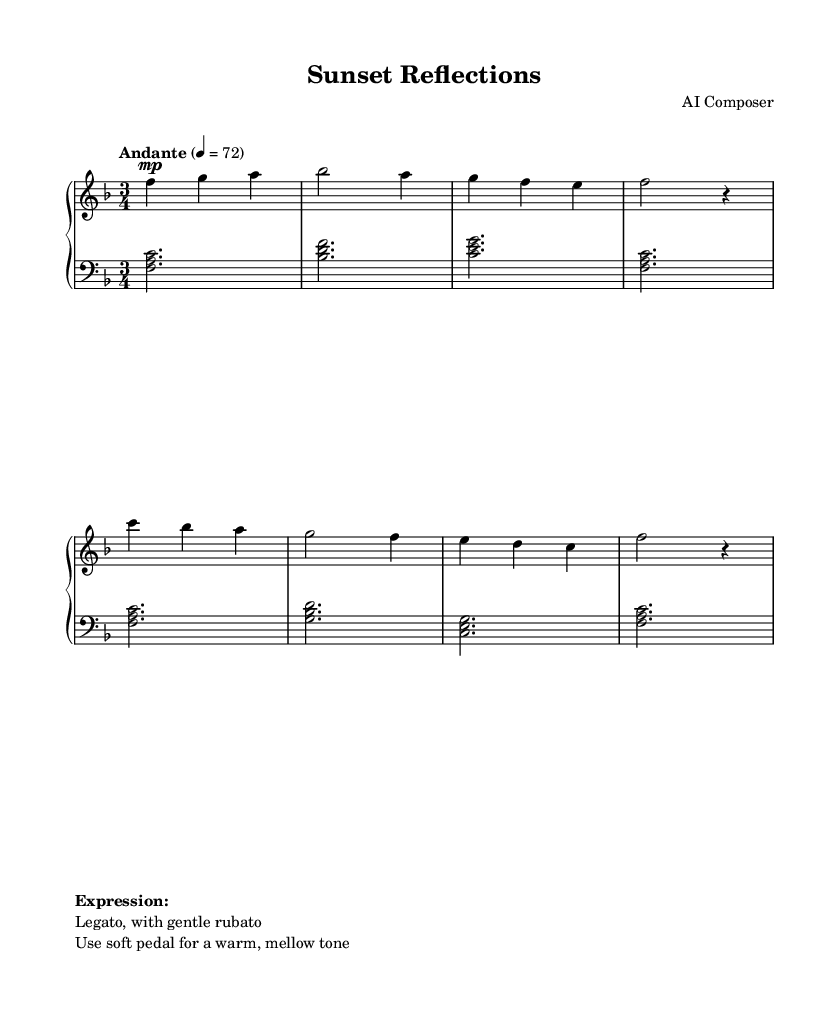What is the key signature of this music? The key signature is F major, which has one flat (B flat). This can be identified at the beginning of the sheet music, where the key signature is placed after the clef.
Answer: F major What is the time signature of this composition? The time signature is 3/4, which means there are three beats per measure and the quarter note gets one beat. This is indicated at the beginning of the sheet music where the time signature is shown.
Answer: 3/4 What is the tempo marking for this piece? The tempo marking is "Andante," indicating a moderate pace; this can be found at the start of the music and is typically given in Italian.
Answer: Andante How many measures are in the music? There are 8 measures in total, which can be counted by identifying each bar line in the score. Each bar line indicates the end of a measure.
Answer: 8 What is the dynamic marking for the upper line at the beginning? The dynamic marking is "mp," which stands for "mezzo piano," meaning moderately soft. This is shown in the first measure of the upper staff.
Answer: mp What type of pedal usage is suggested? The sheet suggests the use of a soft pedal for a warm, mellow tone. This is indicated in the markup at the bottom of the sheet music.
Answer: soft pedal What expression technique is recommended for this piece? The expression technique recommended is "Legato, with gentle rubato." This instruction is also provided in the markup section, guiding how to play the notes smoothly and with slight variations in speed.
Answer: Legato, with gentle rubato 